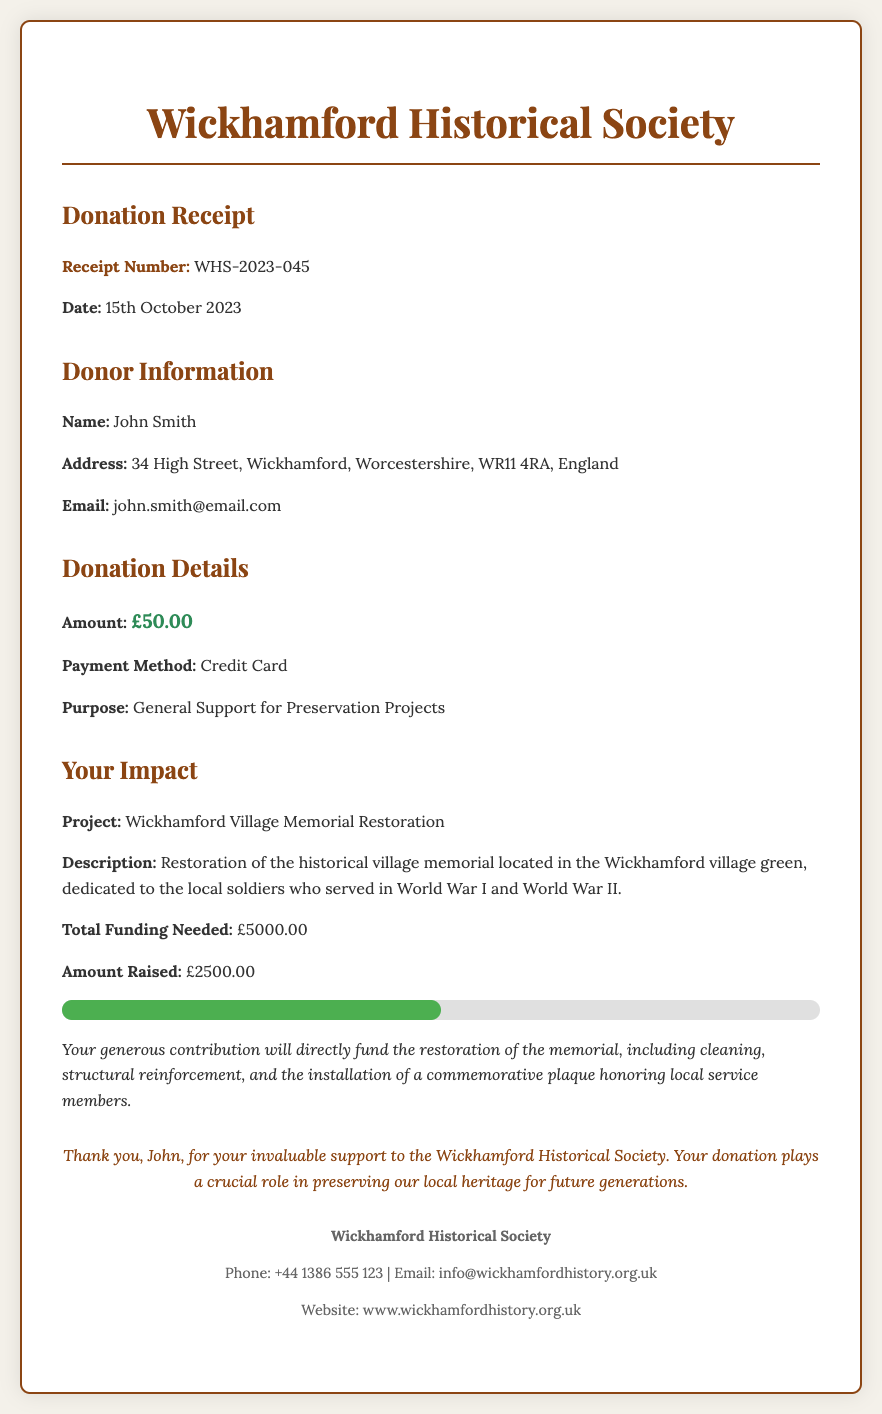What is the receipt number? The receipt number is mentioned in the receipt details section, which is WHS-2023-045.
Answer: WHS-2023-045 What is the donation amount? The donation amount is specified in the donation details section, which states £50.00.
Answer: £50.00 Who is the donor? The donor’s name is listed as John Smith in the donor details section.
Answer: John Smith What is the purpose of the donation? The purpose of the donation can be found in the donation details section, which states General Support for Preservation Projects.
Answer: General Support for Preservation Projects What is the total funding needed for the project? The total funding needed is specified in the impact statement section, which is £5000.00.
Answer: £5000.00 How much has been raised for the project so far? The amount raised for the project is mentioned in the impact statement section, which is £2500.00.
Answer: £2500.00 What project is being funded by this donation? The project being funded is stated in the impact statement section as Wickhamford Village Memorial Restoration.
Answer: Wickhamford Village Memorial Restoration What date was the donation made? The date of the donation is indicated in the receipt details section, which is 15th October 2023.
Answer: 15th October 2023 What is the contact email for the Wickhamford Historical Society? The contact email is provided in the contact info section, which is info@wickhamfordhistory.org.uk.
Answer: info@wickhamfordhistory.org.uk 